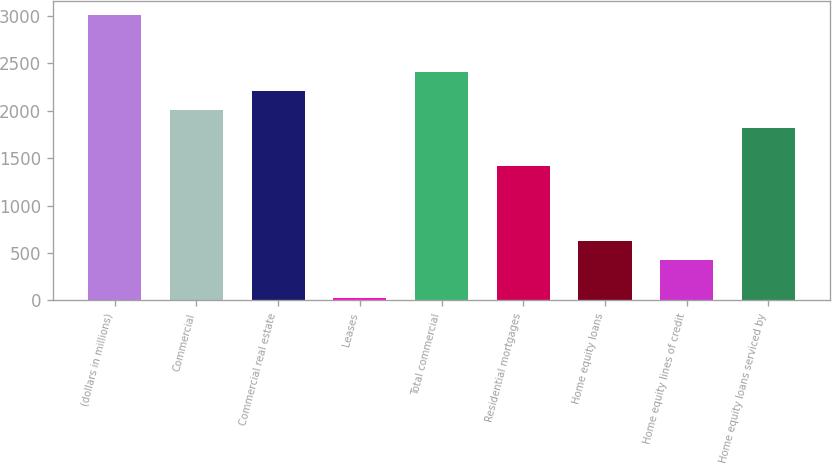Convert chart. <chart><loc_0><loc_0><loc_500><loc_500><bar_chart><fcel>(dollars in millions)<fcel>Commercial<fcel>Commercial real estate<fcel>Leases<fcel>Total commercial<fcel>Residential mortgages<fcel>Home equity loans<fcel>Home equity lines of credit<fcel>Home equity loans serviced by<nl><fcel>3002.5<fcel>2011<fcel>2209.3<fcel>28<fcel>2407.6<fcel>1416.1<fcel>622.9<fcel>424.6<fcel>1812.7<nl></chart> 